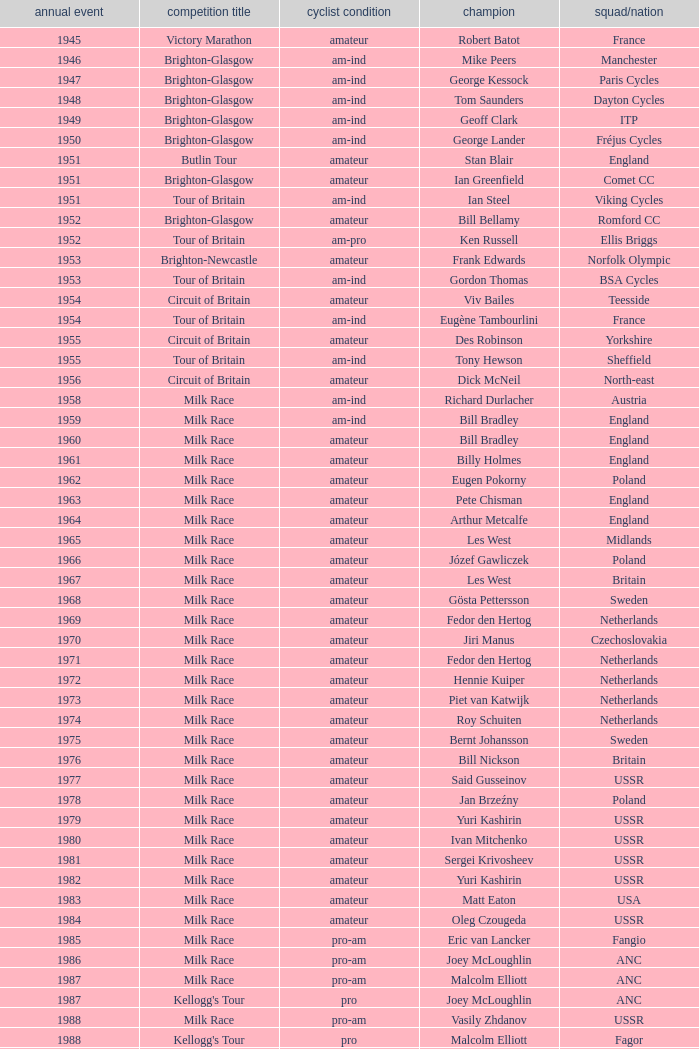What is the rider status for the 1971 netherlands team? Amateur. 